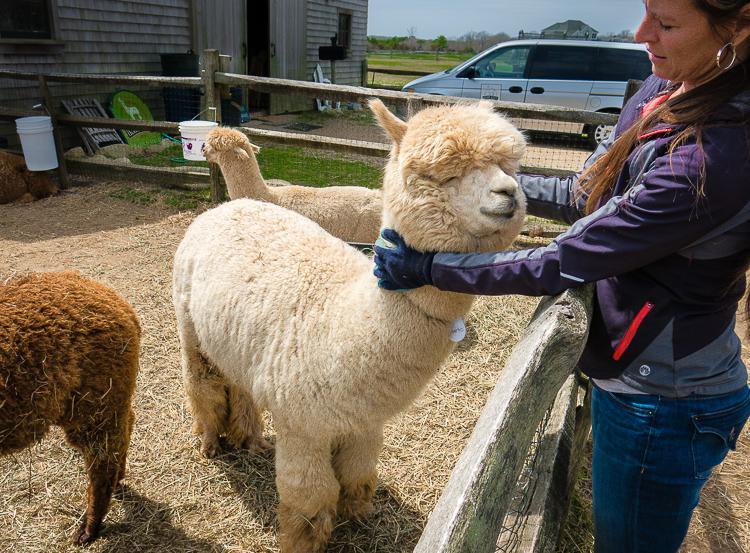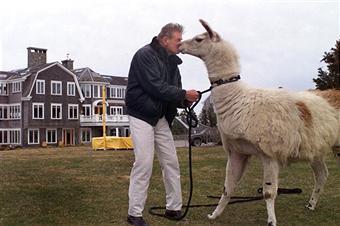The first image is the image on the left, the second image is the image on the right. Given the left and right images, does the statement "There are exactly six llamas in total." hold true? Answer yes or no. No. The first image is the image on the left, the second image is the image on the right. Given the left and right images, does the statement "The left image contains no more than one person interacting with a llama." hold true? Answer yes or no. Yes. 